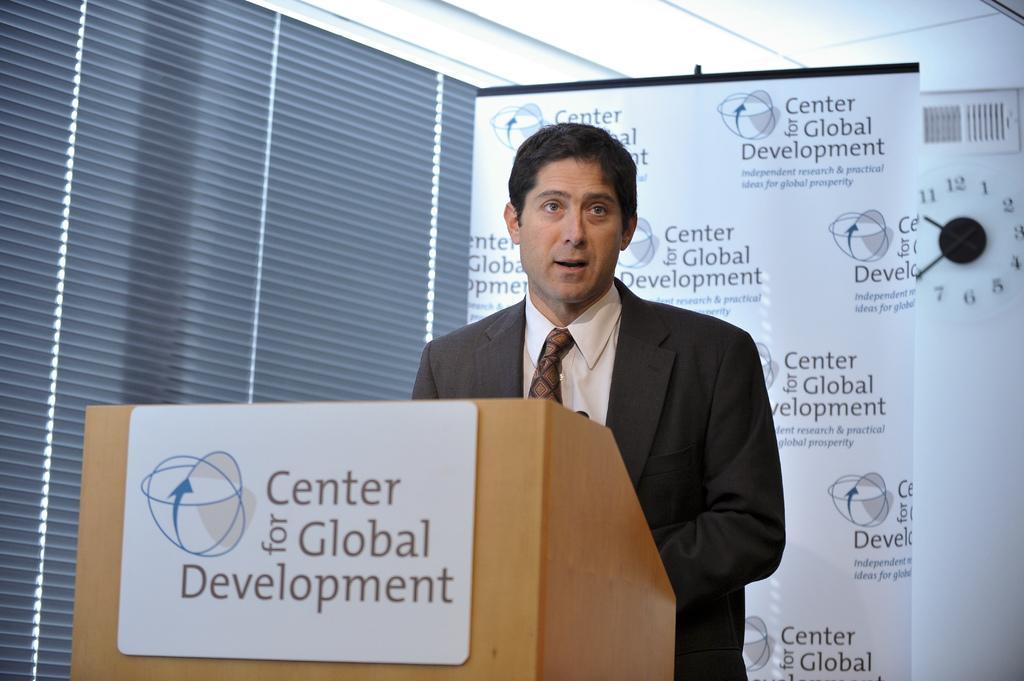Please provide a concise description of this image. In this image I can see a person standing. Behind the person there is a banner or a board. There is a podium with a board attached to it and there is a clock attached to the wall. 